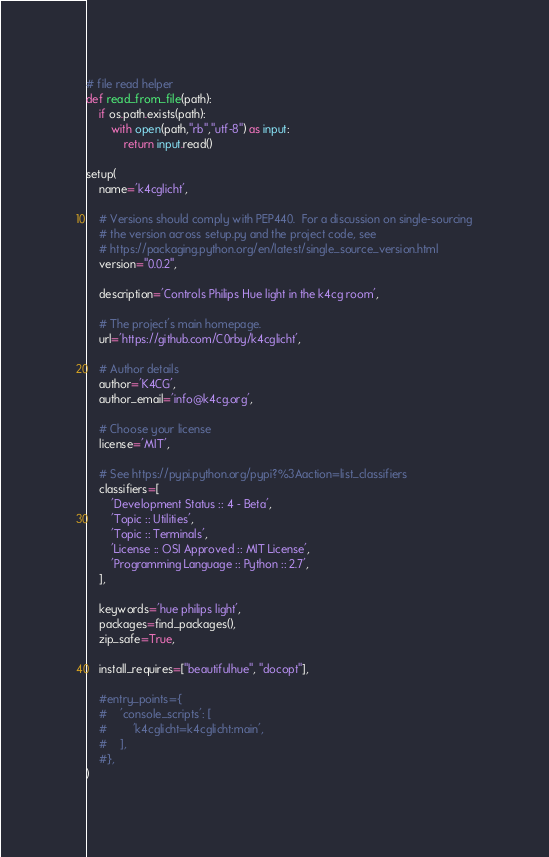Convert code to text. <code><loc_0><loc_0><loc_500><loc_500><_Python_>
# file read helper
def read_from_file(path):
    if os.path.exists(path):
        with open(path,"rb","utf-8") as input:
            return input.read()

setup(
    name='k4cglicht',

    # Versions should comply with PEP440.  For a discussion on single-sourcing
    # the version across setup.py and the project code, see
    # https://packaging.python.org/en/latest/single_source_version.html
    version="0.0.2",

    description='Controls Philips Hue light in the k4cg room',

    # The project's main homepage.
    url='https://github.com/C0rby/k4cglicht',

    # Author details
    author='K4CG',
    author_email='info@k4cg.org',

    # Choose your license
    license='MIT',

    # See https://pypi.python.org/pypi?%3Aaction=list_classifiers
    classifiers=[
        'Development Status :: 4 - Beta',
        'Topic :: Utilities',
        'Topic :: Terminals',
        'License :: OSI Approved :: MIT License',
        'Programming Language :: Python :: 2.7',
    ],

    keywords='hue philips light',
    packages=find_packages(),
    zip_safe=True,

    install_requires=["beautifulhue", "docopt"],

    #entry_points={
    #    'console_scripts': [
    #        'k4cglicht=k4cglicht:main',
    #    ],
    #},
)
</code> 